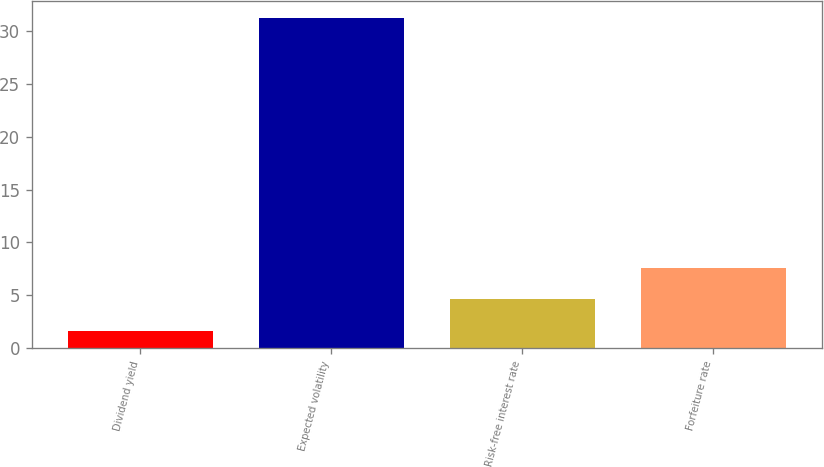<chart> <loc_0><loc_0><loc_500><loc_500><bar_chart><fcel>Dividend yield<fcel>Expected volatility<fcel>Risk-free interest rate<fcel>Forfeiture rate<nl><fcel>1.64<fcel>31.29<fcel>4.6<fcel>7.56<nl></chart> 